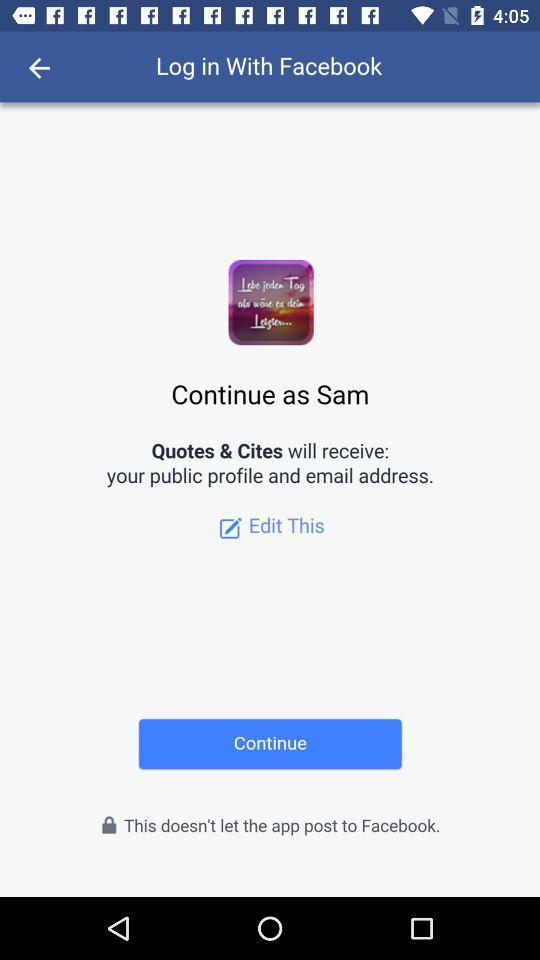What application is asking for permission? The application asking for permission is "Quotes & Cites". 